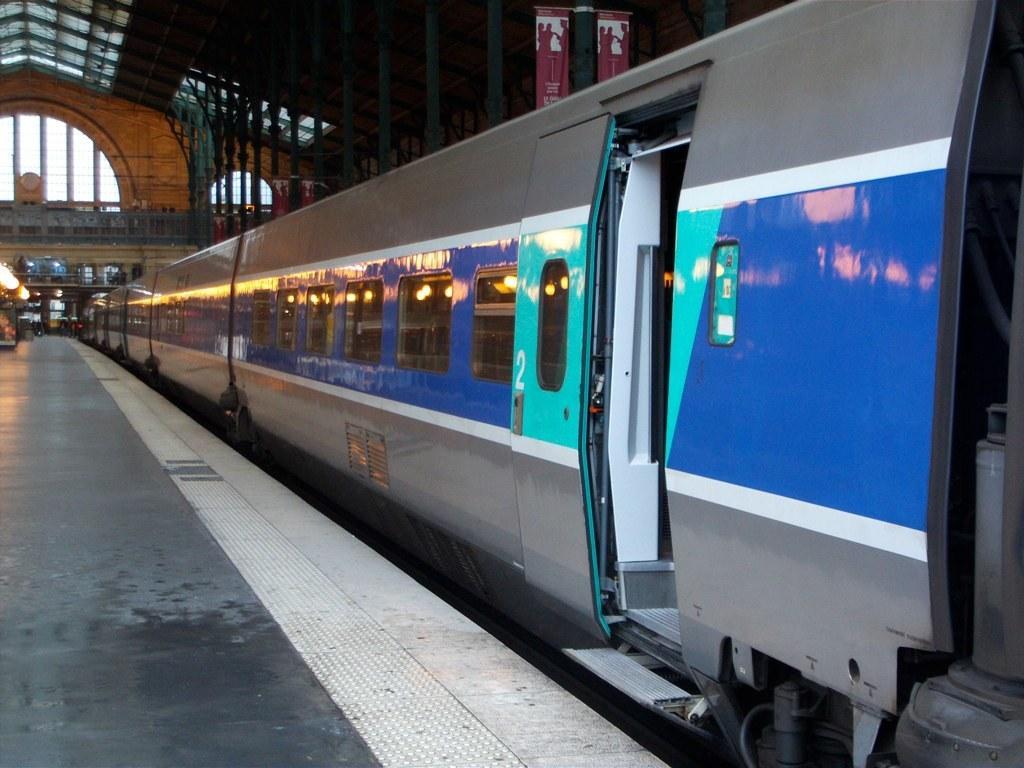Please provide a concise description of this image. In this picture there is a silver and blue color train waiting on the station. Above we can see the metal shed ceiling and a roller poster hanging on it. 